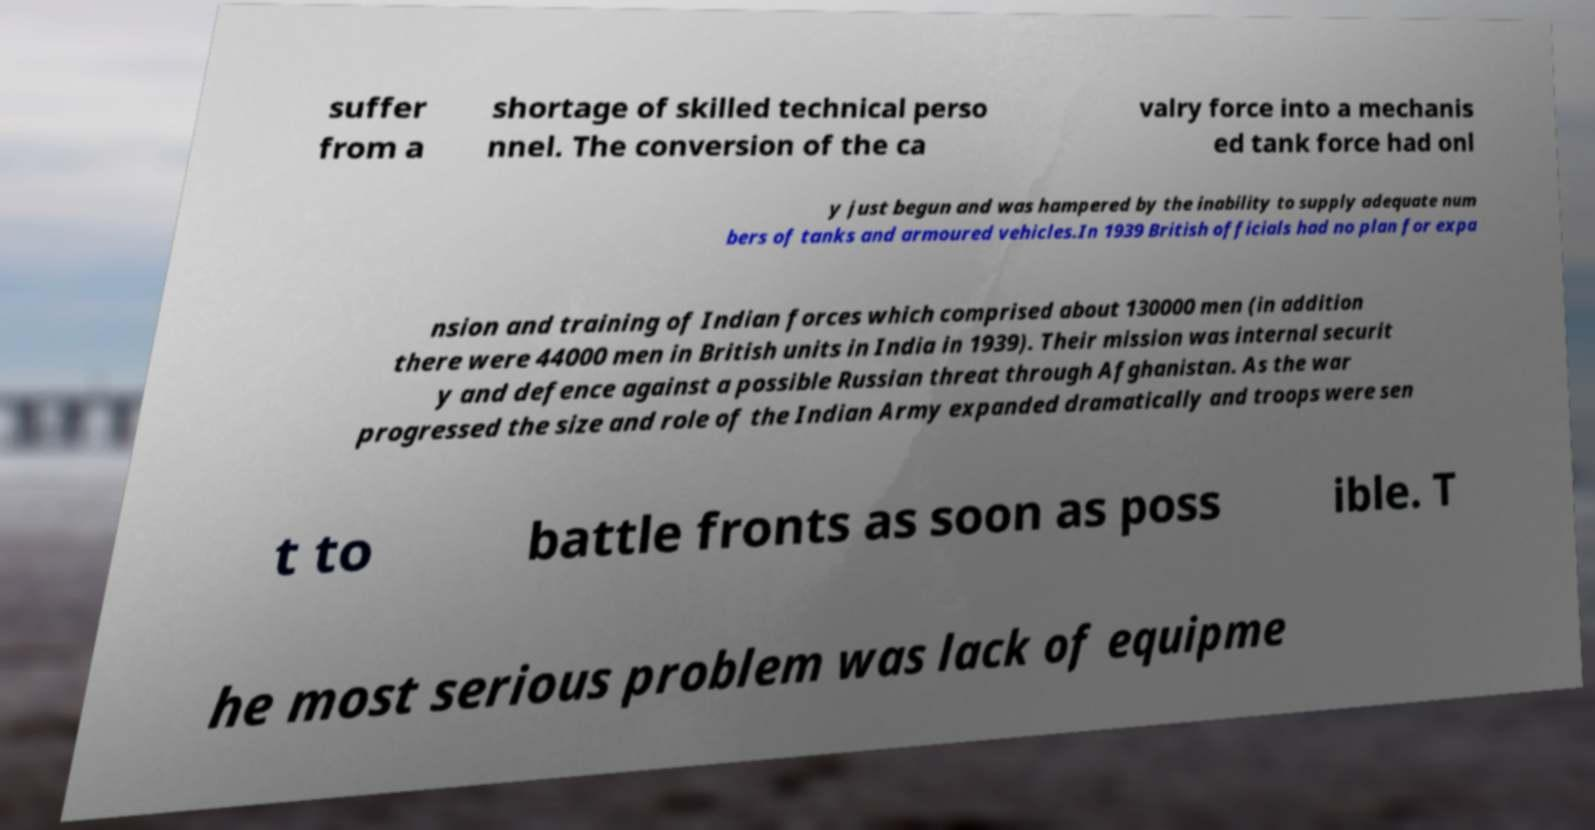Can you read and provide the text displayed in the image?This photo seems to have some interesting text. Can you extract and type it out for me? suffer from a shortage of skilled technical perso nnel. The conversion of the ca valry force into a mechanis ed tank force had onl y just begun and was hampered by the inability to supply adequate num bers of tanks and armoured vehicles.In 1939 British officials had no plan for expa nsion and training of Indian forces which comprised about 130000 men (in addition there were 44000 men in British units in India in 1939). Their mission was internal securit y and defence against a possible Russian threat through Afghanistan. As the war progressed the size and role of the Indian Army expanded dramatically and troops were sen t to battle fronts as soon as poss ible. T he most serious problem was lack of equipme 